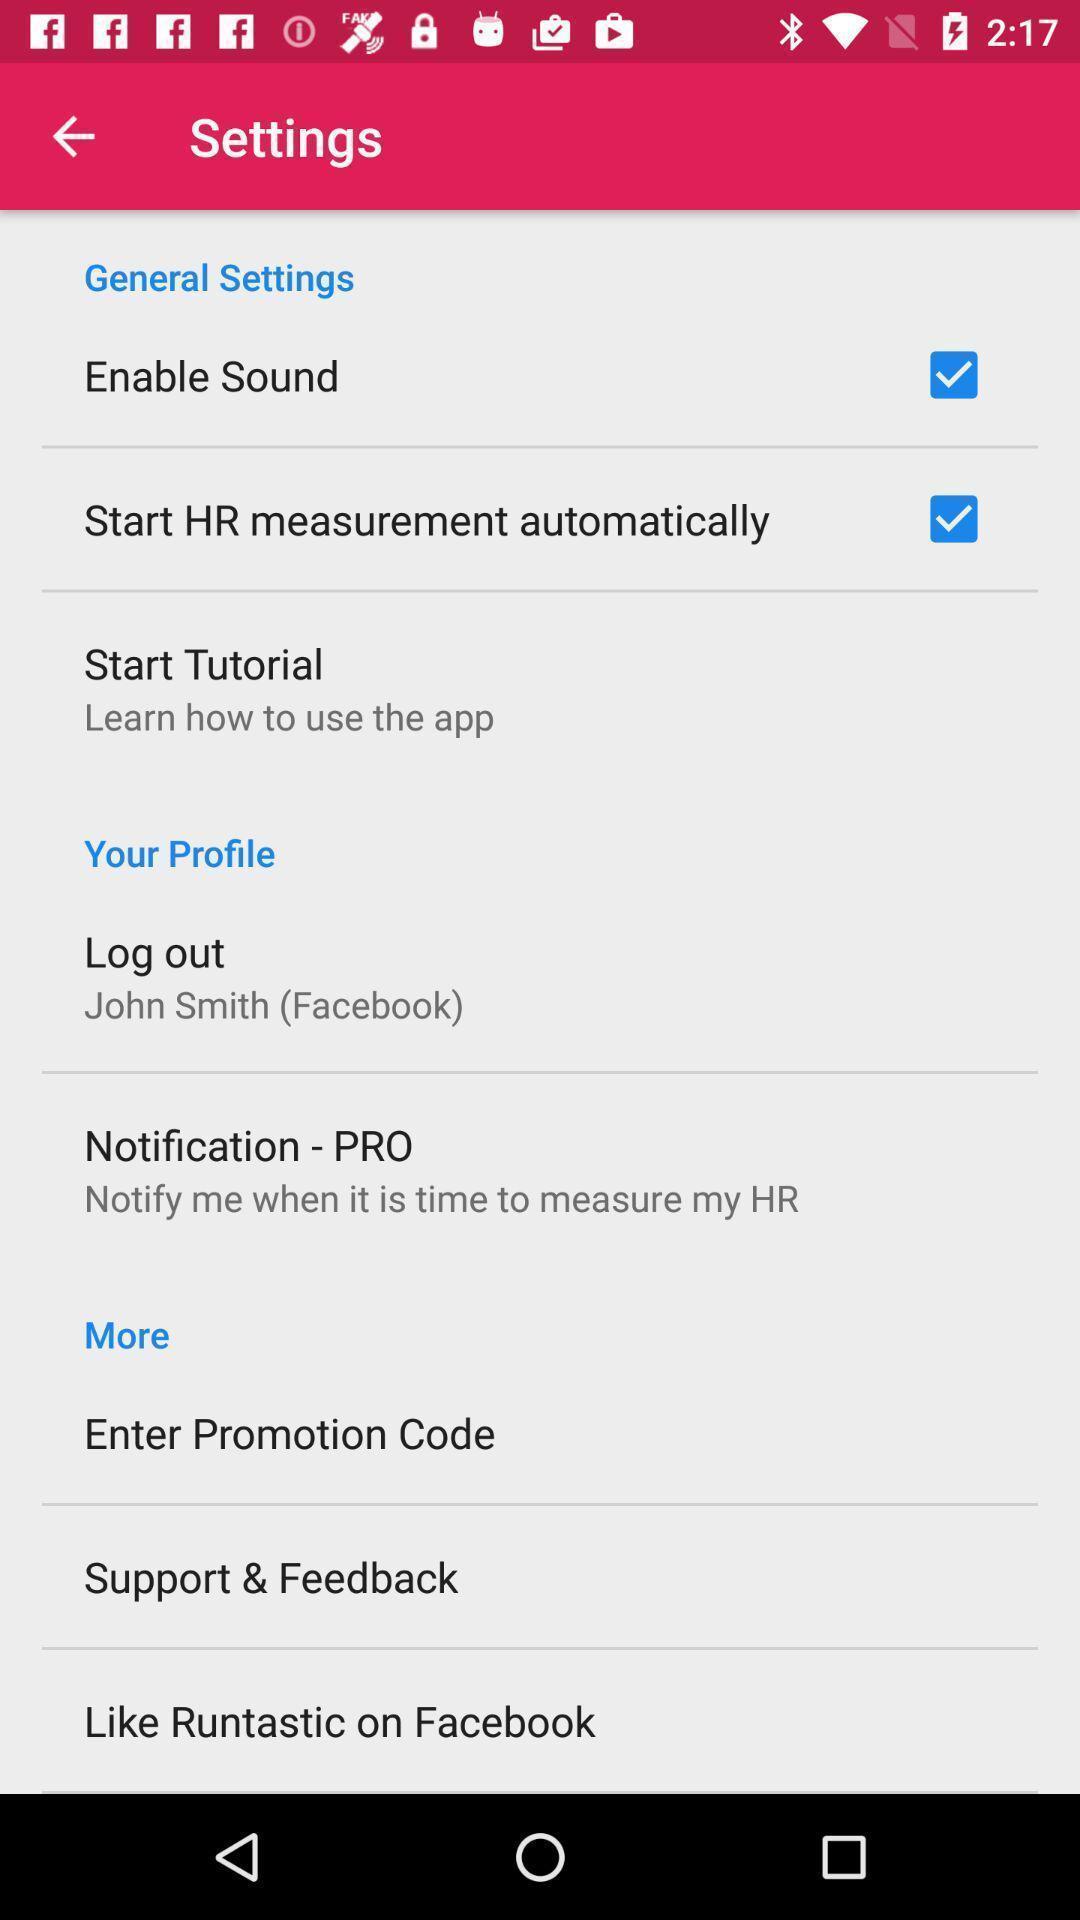What can you discern from this picture? Settings page. 